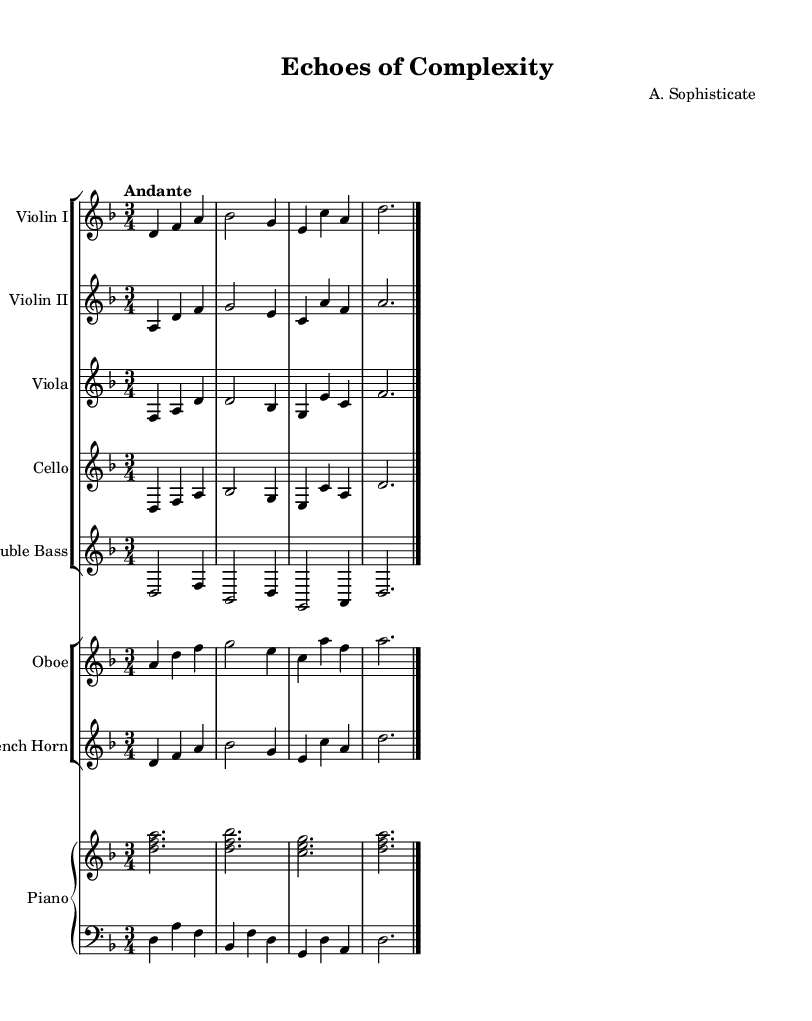What is the key signature of this music? The key signature is indicated at the beginning of the music sheet. It shows two flats (B flat and E flat), which signify that it is in the key of D minor.
Answer: D minor What is the time signature of this music? The time signature is located at the beginning of the sheet music. It is displayed as 3/4, indicating there are three beats per measure, with a quarter note receiving one beat.
Answer: 3/4 What is the tempo marking for this piece? The tempo marking appears at the top of the sheet music. It states "Andante," which indicates a moderate walking pace.
Answer: Andante How many instruments are featured in the orchestration? The orchestration is shown through the staff groups. There are five strings (two violins, viola, cello, double bass), one oboe, one French horn, and one piano. This sums up to a total of eight instruments.
Answer: Eight Which instrument has the highest pitch in this arrangement? By comparing the clefs and ranges, the instrument that appears on the treble clef with the highest pitch notes is the oboe, as it typically plays higher than strings or lower brass instruments.
Answer: Oboe What is the pattern of the piano's left hand in the first two measures? In the first two measures, the left hand of the piano plays a pattern that primarily alternates between the note D and the note A in a steady rhythm. This establishes a harmonic foundation for the piece.
Answer: Alternating D and A What is the dynamic level indicated in this musical section? The dynamic level is shown through notations within the score; however, there are no specific dynamic markings visible in the provided section. Therefore, it relies on interpretation by the performers.
Answer: None indicated 